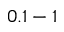Convert formula to latex. <formula><loc_0><loc_0><loc_500><loc_500>0 . 1 - 1</formula> 